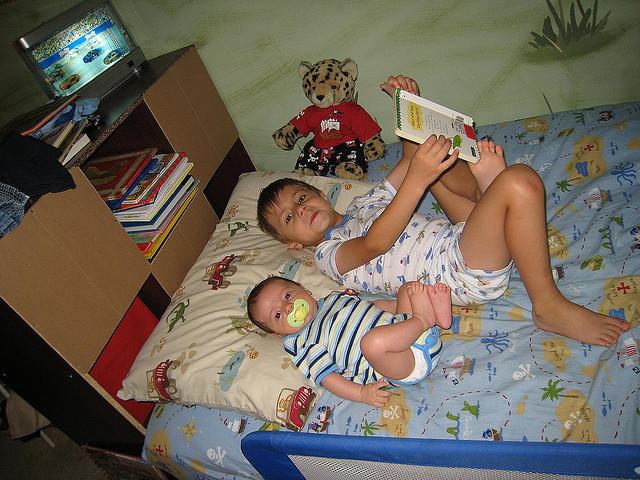Why does she have her leg up?
Write a very short answer. Playing. Is the baby on the left or the right?
Short answer required. Left. How are these children likely related?
Keep it brief. Brothers. What  are these boys doing?
Give a very brief answer. Reading. What kind of clothes is the little boys wearing?
Be succinct. Pajamas. 